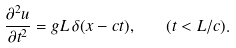<formula> <loc_0><loc_0><loc_500><loc_500>\frac { \partial ^ { 2 } u } { \partial t ^ { 2 } } = g L \, \delta ( x - c t ) , \quad ( t < L / c ) .</formula> 